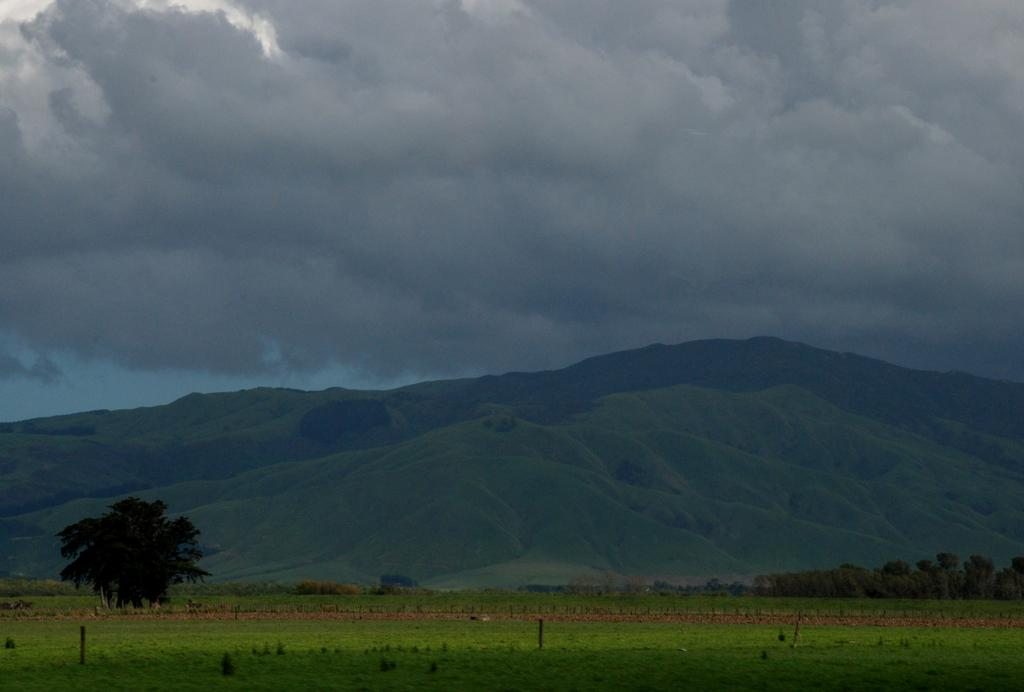What type of vegetation can be seen in the image? There are trees and grass in the image. What type of natural landform is visible in the image? Mountains are visible in the image. What is the condition of the sky in the image? The sky is cloudy in the image. What type of cork can be seen in the image? There is no cork present in the image. Is there a spy visible in the image? There is no indication of a spy in the image, as it features natural elements such as trees, grass, mountains, and a cloudy sky. 